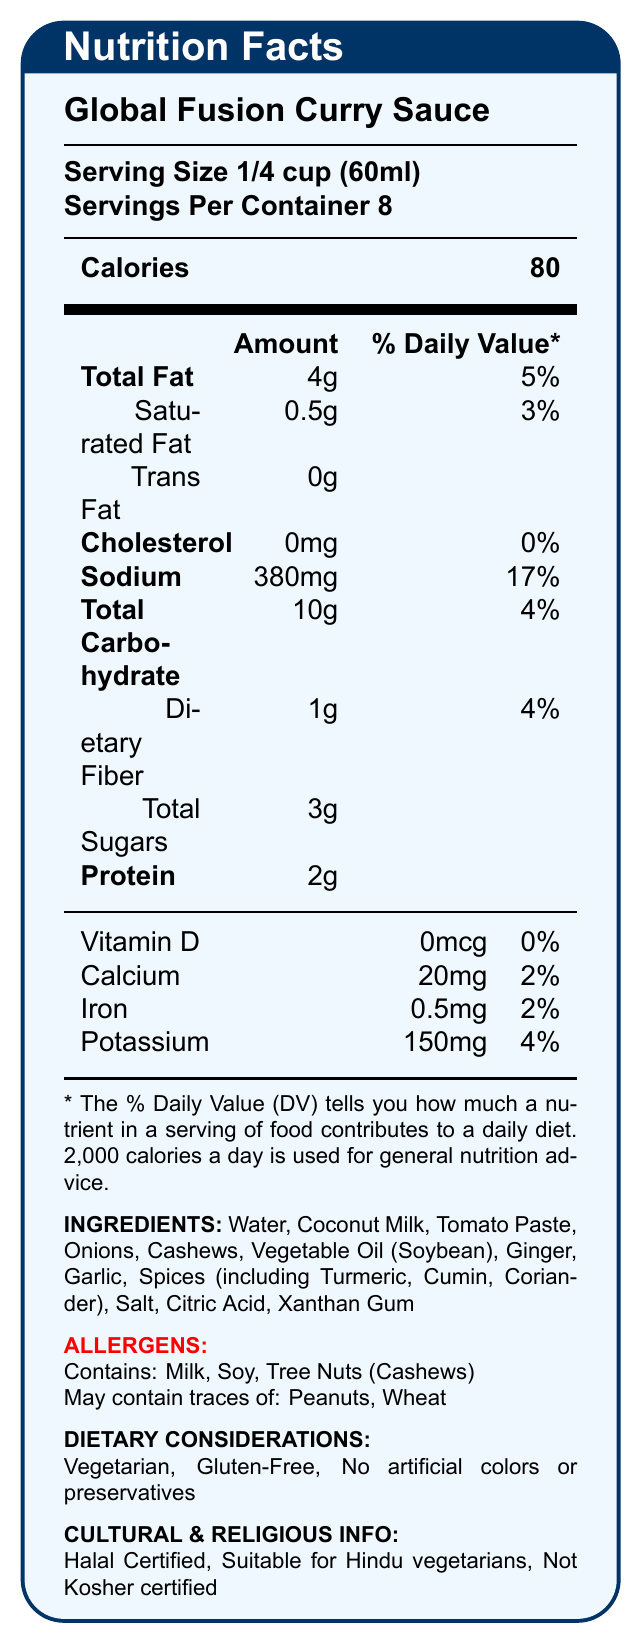What is the serving size for the Global Fusion Curry Sauce? The document specifies the serving size as 1/4 cup (60ml) under the product name.
Answer: 1/4 cup (60ml) How many calories are in a single serving of the curry sauce? The document lists the calories per serving as 80 under the serving size and servings per container details.
Answer: 80 What allergens are present in the Global Fusion Curry Sauce? The allergens section explicitly mentions these ingredients.
Answer: Milk, Soy, Tree Nuts (Cashews); May contain traces of Peanuts, Wheat What is the percentage daily value of sodium per serving? The sodium content and its percent daily value are clearly indicated under the nutrients section.
Answer: 17% Is the Global Fusion Curry Sauce Kosher certified? The document states under cultural and religious info that it is "Not Kosher certified".
Answer: No How many servings are there per container? The document states that there are 8 servings per container just below the serving size.
Answer: 8 Is the product suitable for Hindu vegetarians? The cultural and religious info confirms that it is suitable for Hindu vegetarians.
Answer: Yes What is the total carbohydrate amount per serving? The product lists the total carbohydrate amount as 10g under the nutritional information.
Answer: 10g Which ingredient might concern someone with a peanut allergy? The allergen section specifies that the product may contain traces of peanuts.
Answer: May contain traces of: Peanuts What amount of dietary fiber is found in a single serving? The nutrient information lists Dietary Fiber as 1g.
Answer: 1g What are the dietary considerations mentioned for this product? These considerations are listed under the dietary considerations section.
Answer: Vegetarian, Gluten-Free, No artificial colors or preservatives Which of the following is a potential allergen in the Global Fusion Curry Sauce?
A. Egg
B. Soy
C. Fish The allergen section lists Soy as a potential allergen.
Answer: B What is the percentage daily value of calcium in one serving?
I. 17%
II. 2%
III. 4% The vitamin and mineral section lists the calcium daily value as 2%.
Answer: II Does the Global Fusion Curry Sauce contain any cholesterol? The document lists cholesterol as 0mg with a daily value of 0%.
Answer: No What is the main idea of this document? The document includes the product name, serving size, calories, nutrients, vitamins, minerals, allergens, dietary considerations, and cultural/religious certifications to give a comprehensive view of the product's nutritional profile.
Answer: The document provides detailed nutritional information, ingredient list, allergen warnings, and dietary considerations for Global Fusion Curry Sauce. Can you tell the exact source country of the Global Fusion Curry Sauce from this document? The document does not provide information about the source country of the product.
Answer: Cannot be determined 